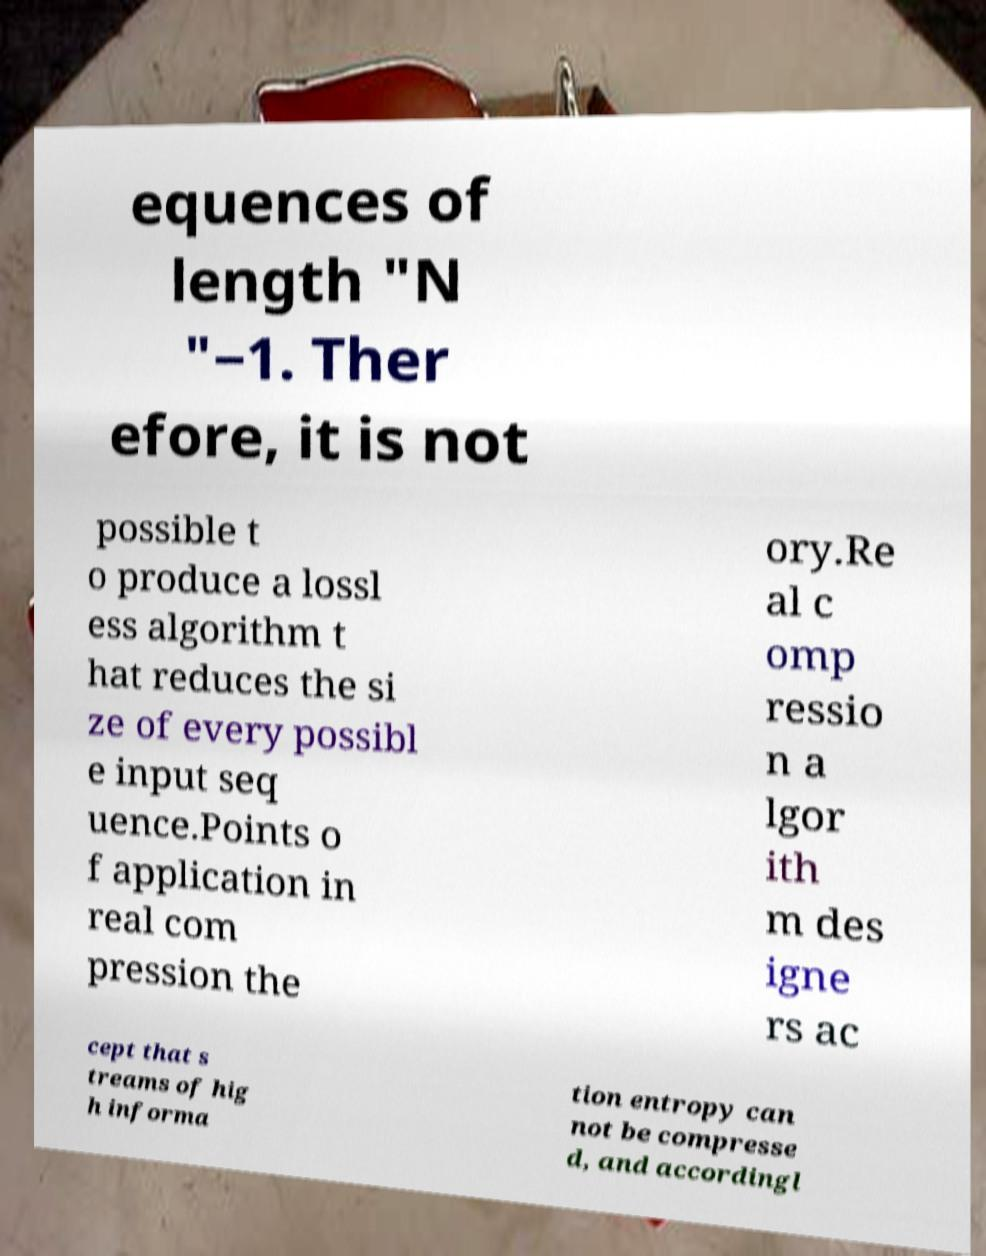Please read and relay the text visible in this image. What does it say? equences of length "N "−1. Ther efore, it is not possible t o produce a lossl ess algorithm t hat reduces the si ze of every possibl e input seq uence.Points o f application in real com pression the ory.Re al c omp ressio n a lgor ith m des igne rs ac cept that s treams of hig h informa tion entropy can not be compresse d, and accordingl 